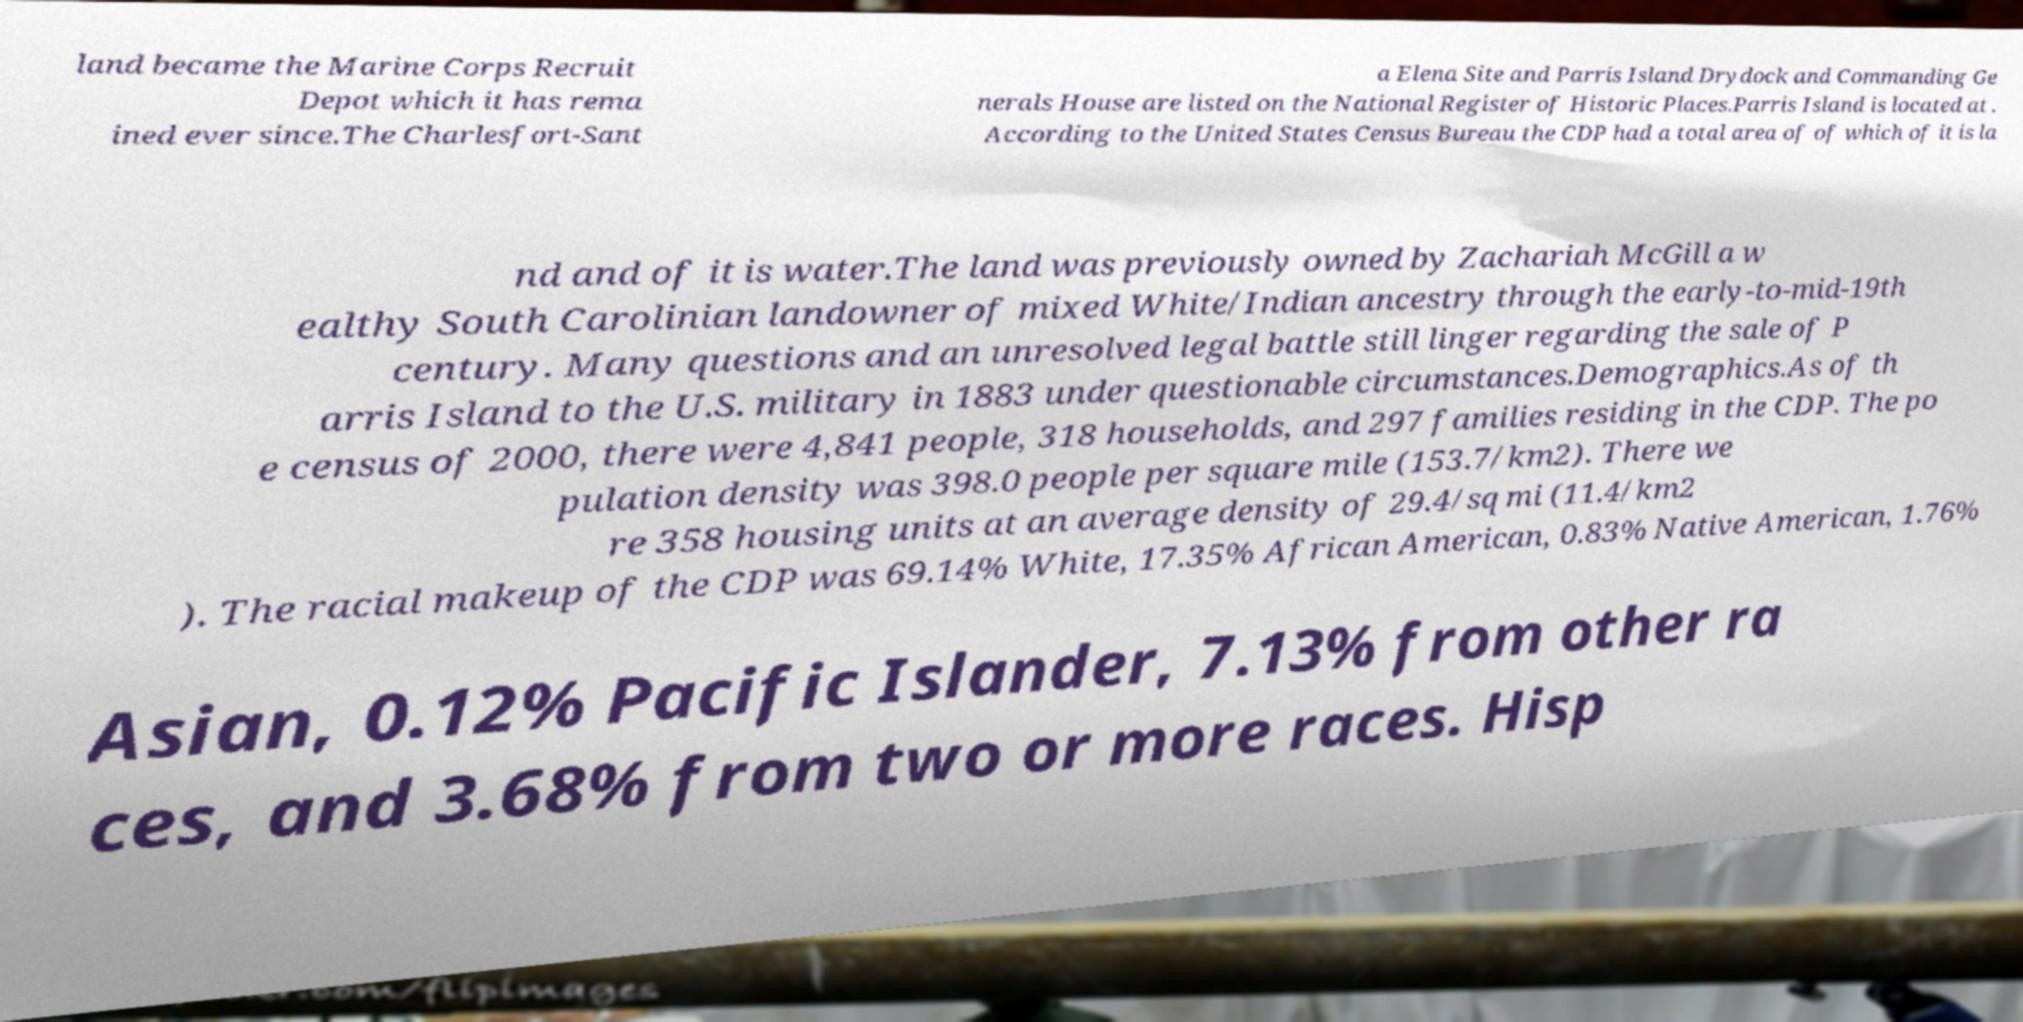I need the written content from this picture converted into text. Can you do that? land became the Marine Corps Recruit Depot which it has rema ined ever since.The Charlesfort-Sant a Elena Site and Parris Island Drydock and Commanding Ge nerals House are listed on the National Register of Historic Places.Parris Island is located at . According to the United States Census Bureau the CDP had a total area of of which of it is la nd and of it is water.The land was previously owned by Zachariah McGill a w ealthy South Carolinian landowner of mixed White/Indian ancestry through the early-to-mid-19th century. Many questions and an unresolved legal battle still linger regarding the sale of P arris Island to the U.S. military in 1883 under questionable circumstances.Demographics.As of th e census of 2000, there were 4,841 people, 318 households, and 297 families residing in the CDP. The po pulation density was 398.0 people per square mile (153.7/km2). There we re 358 housing units at an average density of 29.4/sq mi (11.4/km2 ). The racial makeup of the CDP was 69.14% White, 17.35% African American, 0.83% Native American, 1.76% Asian, 0.12% Pacific Islander, 7.13% from other ra ces, and 3.68% from two or more races. Hisp 